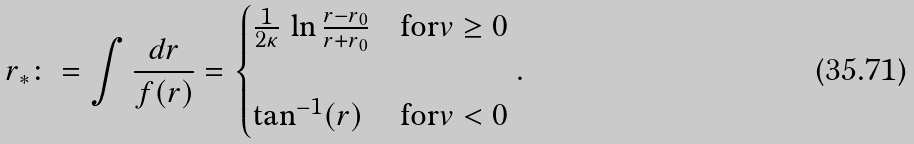Convert formula to latex. <formula><loc_0><loc_0><loc_500><loc_500>& r _ { * } \colon = \int \frac { d r } { f ( r ) } = \begin{cases} \frac { 1 } { 2 \kappa } \, \ln \frac { r - r _ { 0 } } { r + r _ { 0 } } & \text {for} v \geq 0 \\ \\ \tan ^ { - 1 } ( r ) & \text {for} v < 0 \end{cases} .</formula> 